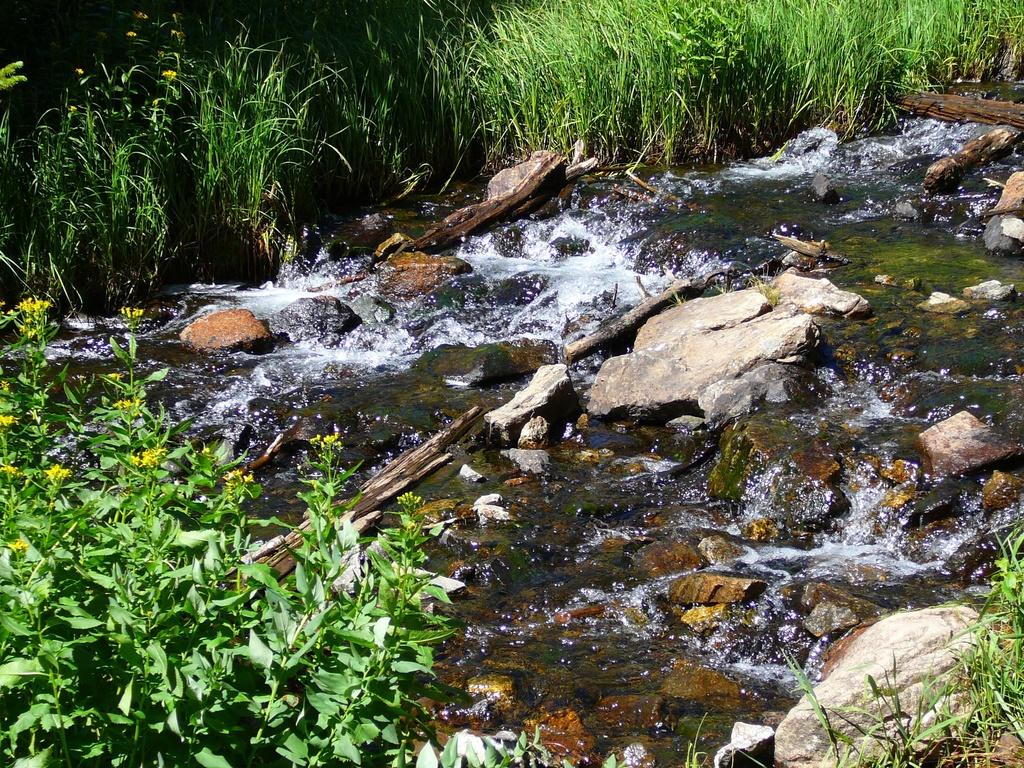What is the primary element in the image? The image consists of water. What can be found at the bottom of the image? There are rocks at the bottom of the image. What type of plants are present on the left side of the image? There are plants with yellow flowers on the left side of the image. What type of vegetation is visible in the background of the image? There is green grass visible in the background of the image. What type of business is being conducted in the image? There is no indication of any business activity in the image, as it primarily consists of water with rocks and plants. What type of treatment is being administered to the rabbit in the image? There is no rabbit present in the image, so no treatment can be administered. 